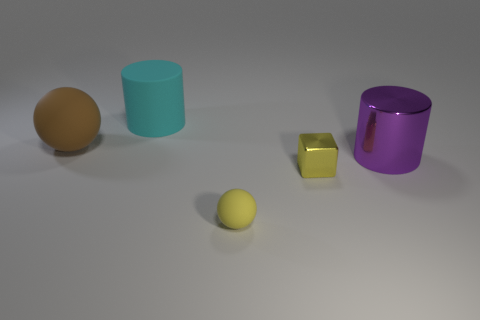There is a small metallic object that is the same color as the small ball; what is its shape?
Your answer should be very brief. Cube. How many other things are the same size as the cyan matte thing?
Give a very brief answer. 2. There is a object that is the same color as the tiny ball; what size is it?
Your answer should be very brief. Small. Is there a cube made of the same material as the big brown thing?
Provide a short and direct response. No. Is the color of the metallic object that is to the left of the big purple object the same as the small rubber object?
Provide a short and direct response. Yes. How big is the cyan rubber object?
Your answer should be very brief. Large. There is a cyan rubber object that is left of the small thing behind the small yellow sphere; are there any large purple metal cylinders that are left of it?
Provide a succinct answer. No. What number of large cyan matte cylinders are left of the cyan cylinder?
Offer a very short reply. 0. How many small things are the same color as the tiny ball?
Provide a succinct answer. 1. What number of things are either yellow objects that are on the left side of the tiny metallic block or objects behind the purple metal cylinder?
Offer a terse response. 3. 